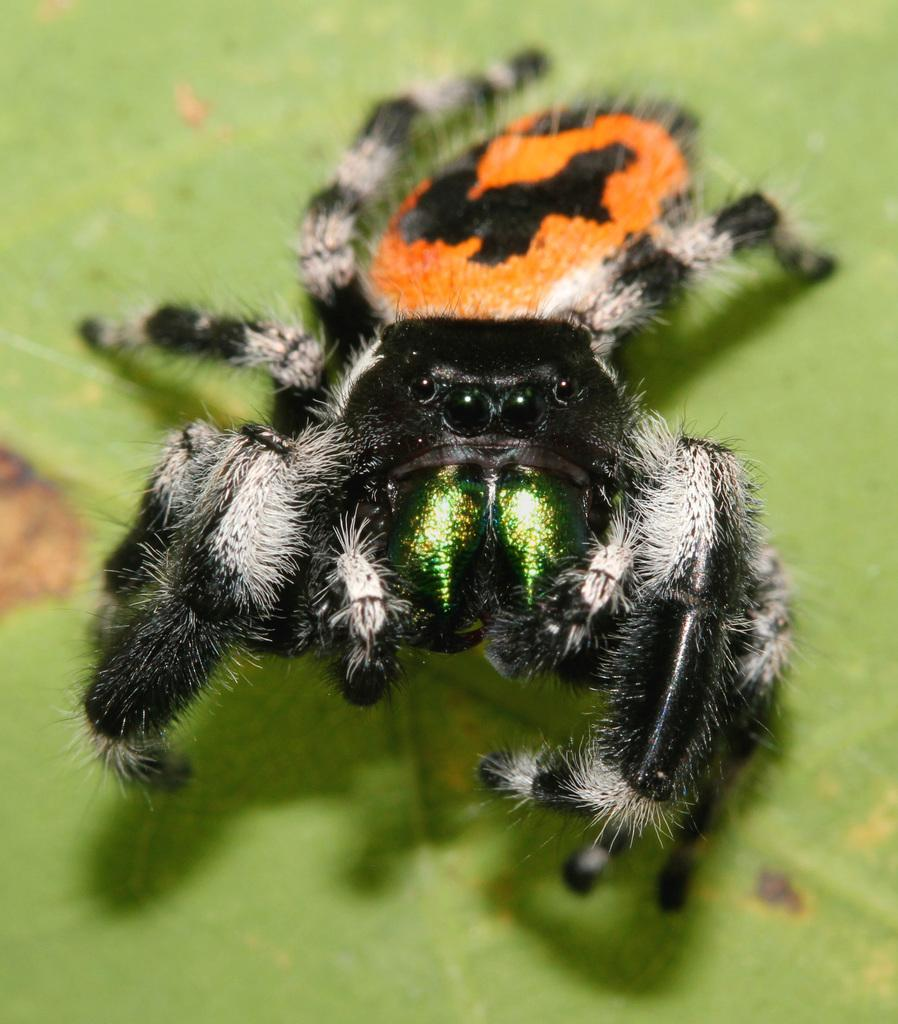What type of plant material is present in the image? There is a green leaf in the image. What type of animal is present in the image? There is a spider in the image. How many legs does the spider have? The spider has legs, but the exact number is not mentioned in the facts. What colors can be seen on the spider? The spider has white, black, and orange colors on it. What type of stamp can be seen on the leaf in the image? There is no stamp present on the leaf in the image. What type of insurance policy is mentioned in the image? There is no mention of insurance in the image. 